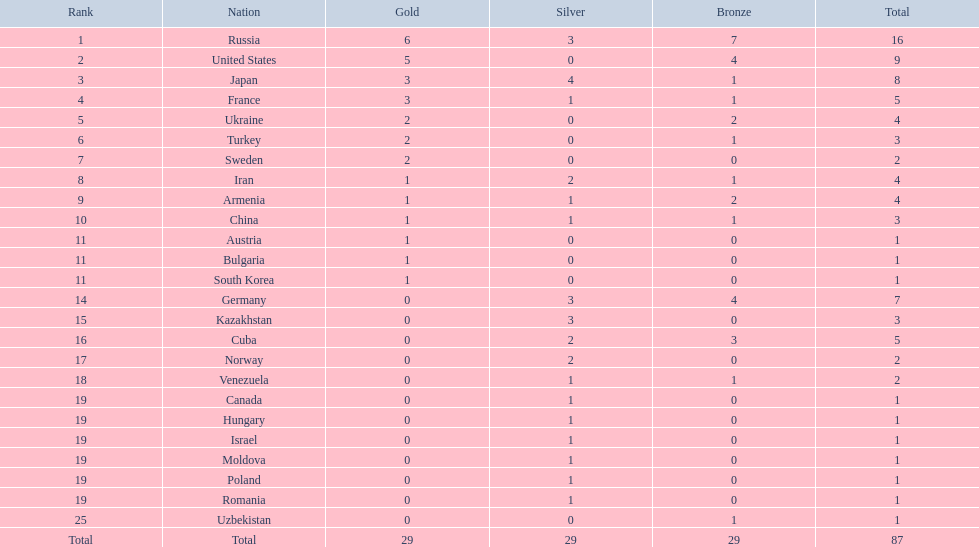What are the different countries? Russia, 6, United States, 5, Japan, 3, France, 3, Ukraine, 2, Turkey, 2, Sweden, 2, Iran, 1, Armenia, 1, China, 1, Austria, 1, Bulgaria, 1, South Korea, 1, Germany, 0, Kazakhstan, 0, Cuba, 0, Norway, 0, Venezuela, 0, Canada, 0, Hungary, 0, Israel, 0, Moldova, 0, Poland, 0, Romania, 0, Uzbekistan, 0. Which countries have claimed gold? Russia, 6, United States, 5, Japan, 3, France, 3, Ukraine, 2, Turkey, 2, Sweden, 2, Iran, 1, Armenia, 1, China, 1, Austria, 1, Bulgaria, 1, South Korea, 1. How many gold medals have the united states obtained? United States, 5. Which nation boasts more than 5 gold medals? Russia, 6. Can you identify the country in question? Russia. Which countries possess a single gold medal? Iran, Armenia, China, Austria, Bulgaria, South Korea. Among them, which countries have no silver medals? Austria, Bulgaria, South Korea. Furthermore, which of these countries have no bronze medals as well? Austria. 